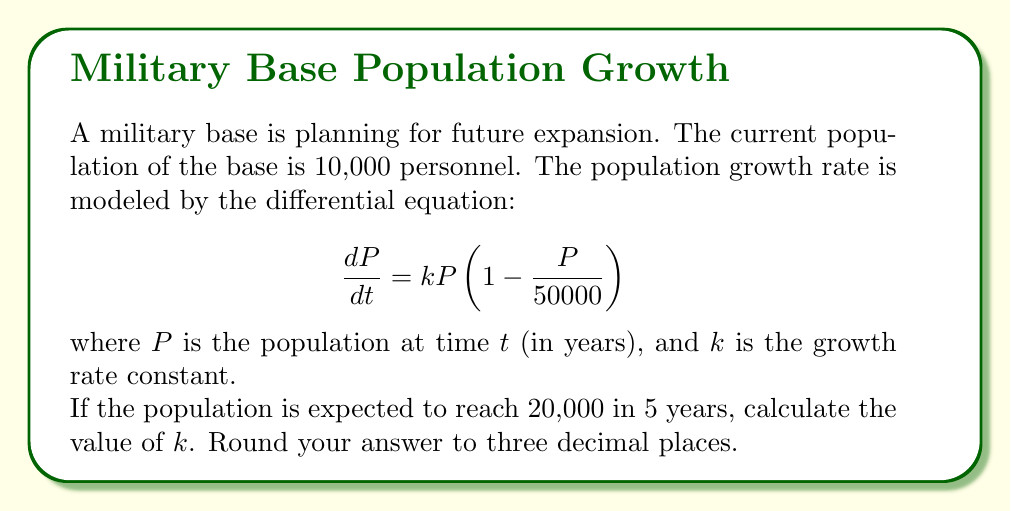Show me your answer to this math problem. Let's approach this step-by-step:

1) We're given the logistic growth model:
   $$\frac{dP}{dt} = kP(1 - \frac{P}{50000})$$

2) The solution to this differential equation is:
   $$P(t) = \frac{50000}{1 + (\frac{50000}{P_0} - 1)e^{-kt}}$$
   where $P_0$ is the initial population.

3) We know:
   - $P_0 = 10000$ (initial population)
   - $P(5) = 20000$ (population after 5 years)
   - $t = 5$ (time in years)

4) Let's substitute these values into our solution:
   $$20000 = \frac{50000}{1 + (\frac{50000}{10000} - 1)e^{-5k}}$$

5) Simplify:
   $$20000 = \frac{50000}{1 + 4e^{-5k}}$$

6) Multiply both sides by $(1 + 4e^{-5k})$:
   $$20000(1 + 4e^{-5k}) = 50000$$

7) Expand:
   $$20000 + 80000e^{-5k} = 50000$$

8) Subtract 20000 from both sides:
   $$80000e^{-5k} = 30000$$

9) Divide both sides by 80000:
   $$e^{-5k} = \frac{3}{8}$$

10) Take the natural log of both sides:
    $$-5k = \ln(\frac{3}{8})$$

11) Solve for $k$:
    $$k = -\frac{1}{5}\ln(\frac{3}{8}) \approx 0.196$$

12) Round to three decimal places: $k = 0.196$
Answer: $k = 0.196$ 